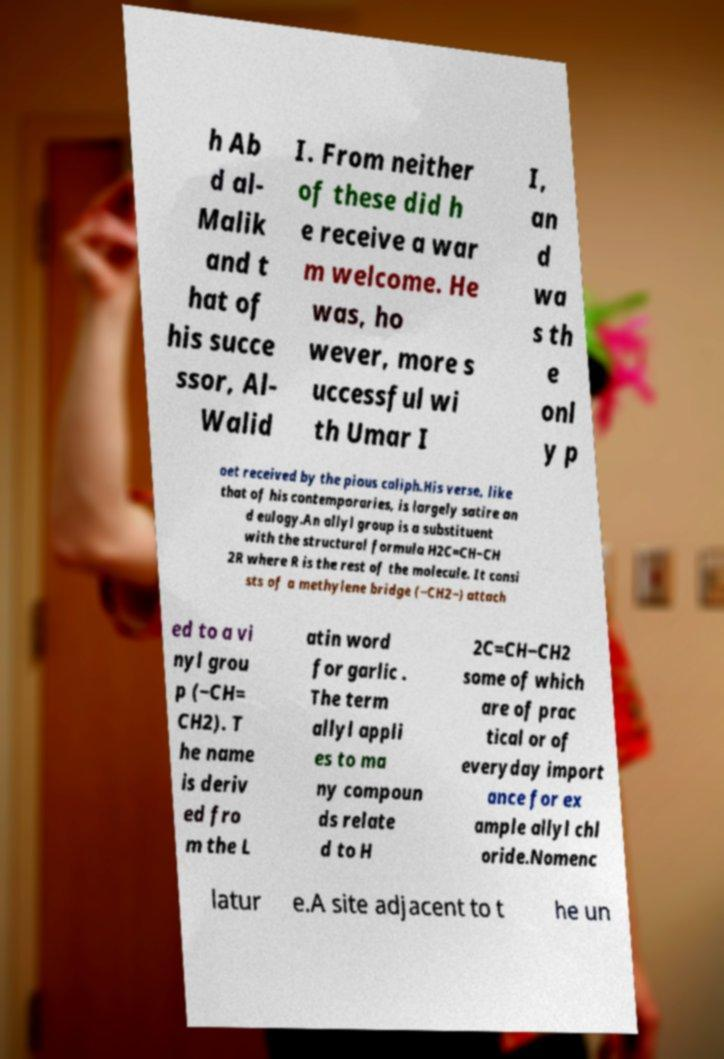Could you assist in decoding the text presented in this image and type it out clearly? h Ab d al- Malik and t hat of his succe ssor, Al- Walid I. From neither of these did h e receive a war m welcome. He was, ho wever, more s uccessful wi th Umar I I, an d wa s th e onl y p oet received by the pious caliph.His verse, like that of his contemporaries, is largely satire an d eulogy.An allyl group is a substituent with the structural formula H2C=CH−CH 2R where R is the rest of the molecule. It consi sts of a methylene bridge (−CH2−) attach ed to a vi nyl grou p (−CH= CH2). T he name is deriv ed fro m the L atin word for garlic . The term allyl appli es to ma ny compoun ds relate d to H 2C=CH−CH2 some of which are of prac tical or of everyday import ance for ex ample allyl chl oride.Nomenc latur e.A site adjacent to t he un 